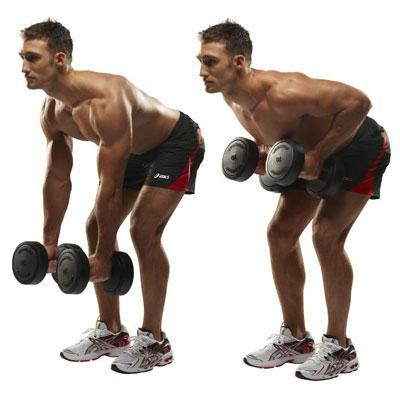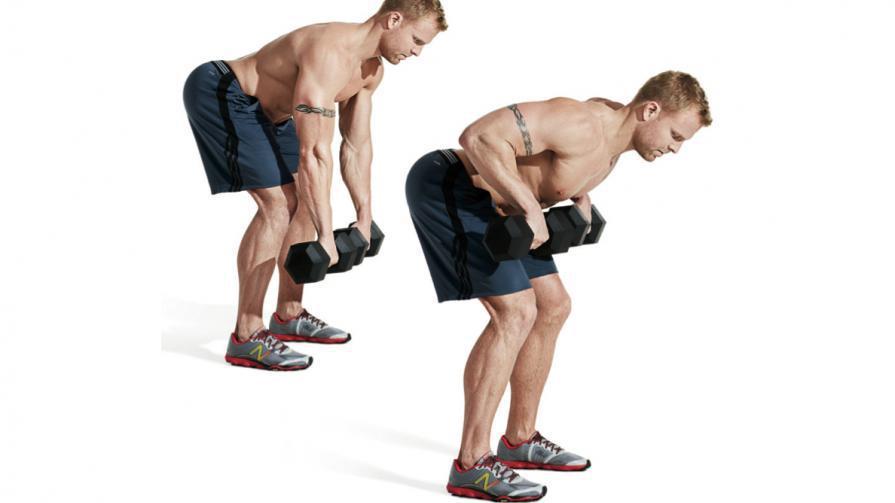The first image is the image on the left, the second image is the image on the right. Considering the images on both sides, is "Each image includes the same number of people, and each person is demonstrating the same type of workout and wearing the same attire." valid? Answer yes or no. Yes. The first image is the image on the left, the second image is the image on the right. Considering the images on both sides, is "There are at least two humans in the left image." valid? Answer yes or no. Yes. 